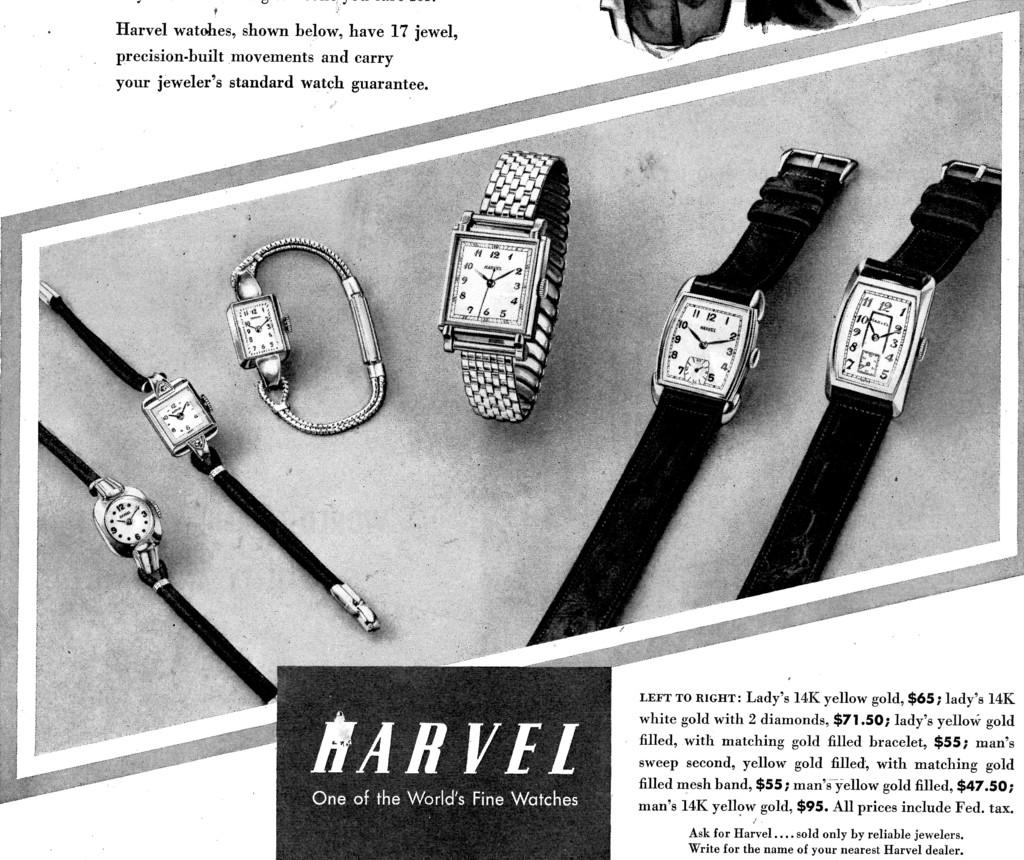<image>
Provide a brief description of the given image. A vintage black and white advertisement for Harvel men's and women's wristwatches. 